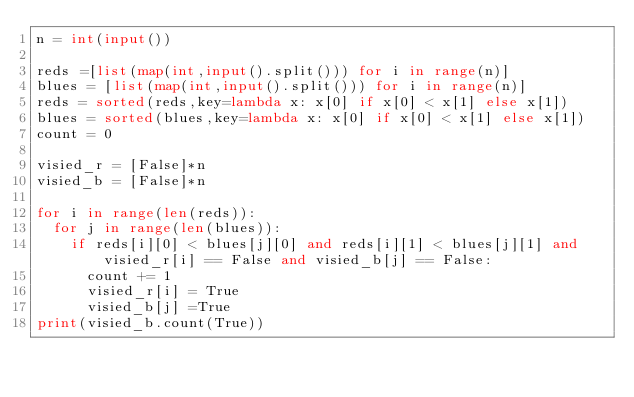Convert code to text. <code><loc_0><loc_0><loc_500><loc_500><_Python_>n = int(input())

reds =[list(map(int,input().split())) for i in range(n)]
blues = [list(map(int,input().split())) for i in range(n)]
reds = sorted(reds,key=lambda x: x[0] if x[0] < x[1] else x[1])
blues = sorted(blues,key=lambda x: x[0] if x[0] < x[1] else x[1])
count = 0

visied_r = [False]*n
visied_b = [False]*n

for i in range(len(reds)):
  for j in range(len(blues)):
    if reds[i][0] < blues[j][0] and reds[i][1] < blues[j][1] and visied_r[i] == False and visied_b[j] == False:
      count += 1
      visied_r[i] = True
      visied_b[j] =True
print(visied_b.count(True))</code> 